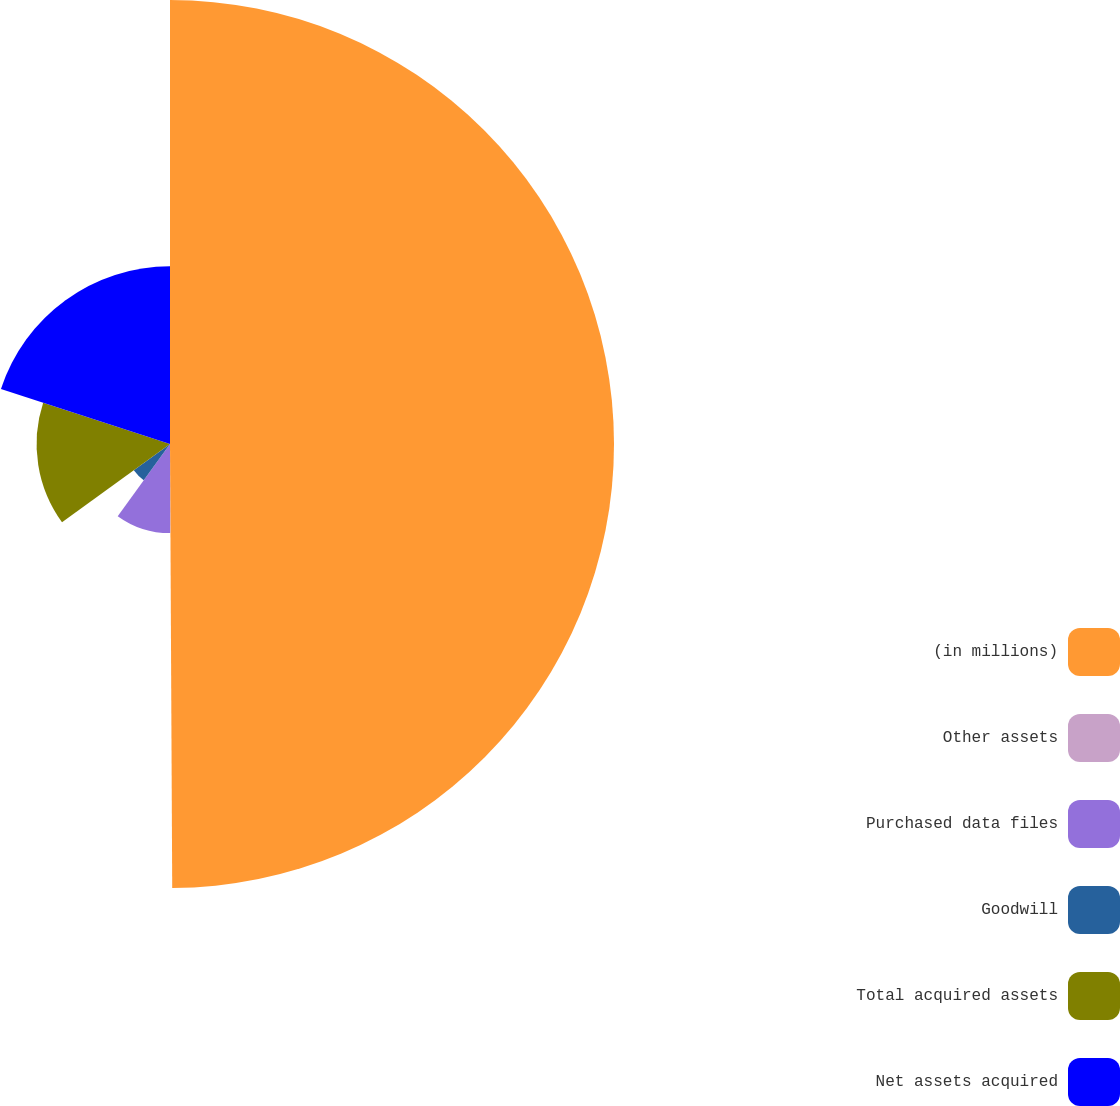<chart> <loc_0><loc_0><loc_500><loc_500><pie_chart><fcel>(in millions)<fcel>Other assets<fcel>Purchased data files<fcel>Goodwill<fcel>Total acquired assets<fcel>Net assets acquired<nl><fcel>49.92%<fcel>0.04%<fcel>10.02%<fcel>5.03%<fcel>15.0%<fcel>19.99%<nl></chart> 